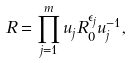<formula> <loc_0><loc_0><loc_500><loc_500>R = \prod _ { j = 1 } ^ { m } u _ { j } R _ { 0 } ^ { \epsilon _ { j } } u _ { j } ^ { - 1 } ,</formula> 